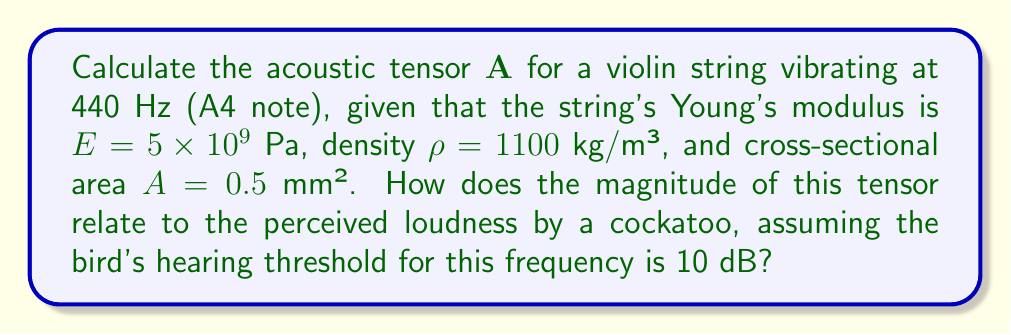What is the answer to this math problem? 1. The acoustic tensor $\mathbf{A}$ for a one-dimensional vibrating string is given by:

   $$\mathbf{A} = \rho c^2$$

   where $\rho$ is the density and $c$ is the wave speed.

2. Calculate the wave speed $c$ using the formula:

   $$c = \sqrt{\frac{E}{\rho}}$$

   $$c = \sqrt{\frac{5 \times 10^9}{1100}} = 2132.01 \text{ m/s}$$

3. Now calculate the acoustic tensor:

   $$\mathbf{A} = 1100 \times (2132.01)^2 = 4.99 \times 10^9 \text{ Pa}$$

4. The magnitude of the acoustic tensor relates to the sound intensity $I$:

   $$I = \frac{1}{2\rho c} (\mathbf{A} : \mathbf{\varepsilon})^2$$

   where $\mathbf{\varepsilon}$ is the strain tensor.

5. Assuming a small strain amplitude of $10^{-6}$, we can estimate the intensity:

   $$I \approx \frac{1}{2 \times 1100 \times 2132.01} (4.99 \times 10^9 \times 10^{-6})^2 = 2.71 \times 10^{-3} \text{ W/m²}$$

6. Convert intensity to sound pressure level (SPL):

   $$\text{SPL} = 10 \log_{10}\left(\frac{I}{I_0}\right) \text{ dB}$$

   where $I_0 = 10^{-12} \text{ W/m²}$ is the reference intensity.

   $$\text{SPL} = 10 \log_{10}\left(\frac{2.71 \times 10^{-3}}{10^{-12}}\right) = 94.33 \text{ dB}$$

7. The perceived loudness by the cockatoo is the difference between the calculated SPL and the bird's hearing threshold:

   $$\text{Perceived Loudness} = 94.33 - 10 = 84.33 \text{ dB}$$
Answer: $\mathbf{A} = 4.99 \times 10^9 \text{ Pa}$; Perceived Loudness = 84.33 dB 